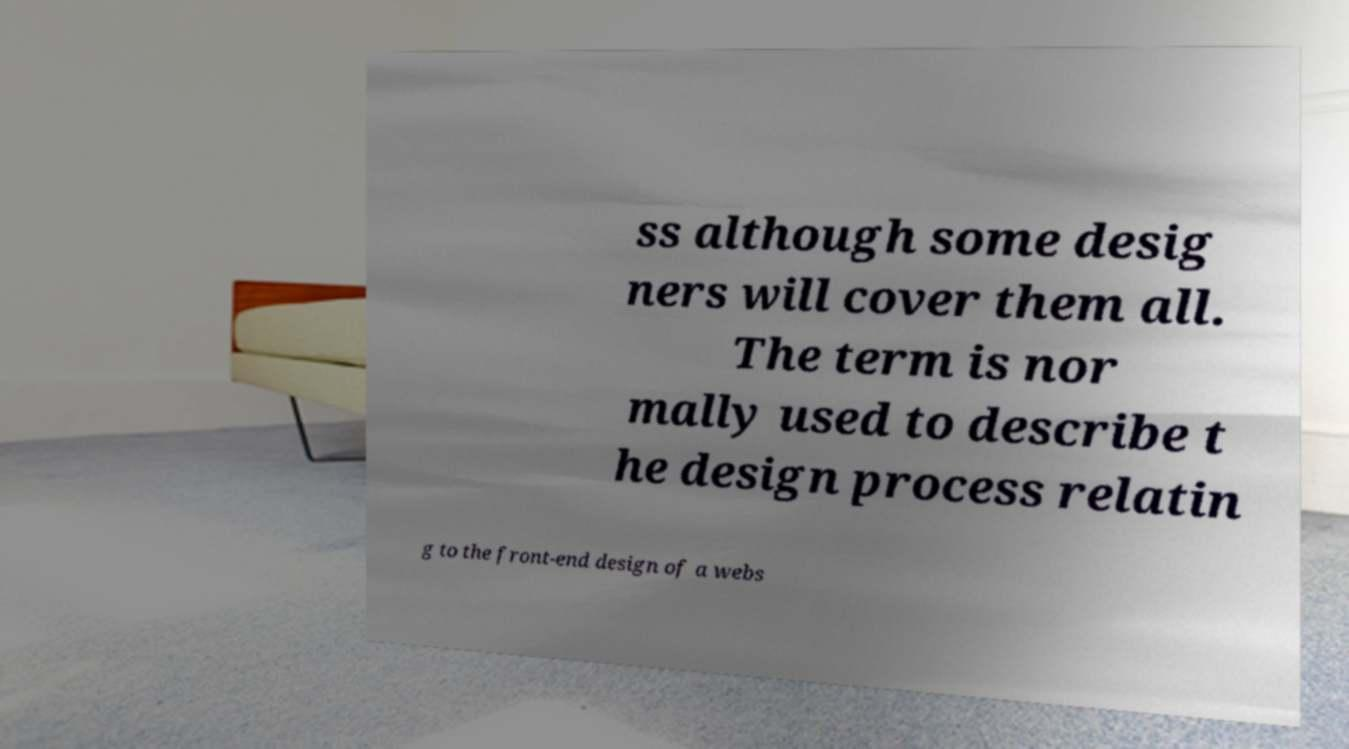There's text embedded in this image that I need extracted. Can you transcribe it verbatim? ss although some desig ners will cover them all. The term is nor mally used to describe t he design process relatin g to the front-end design of a webs 